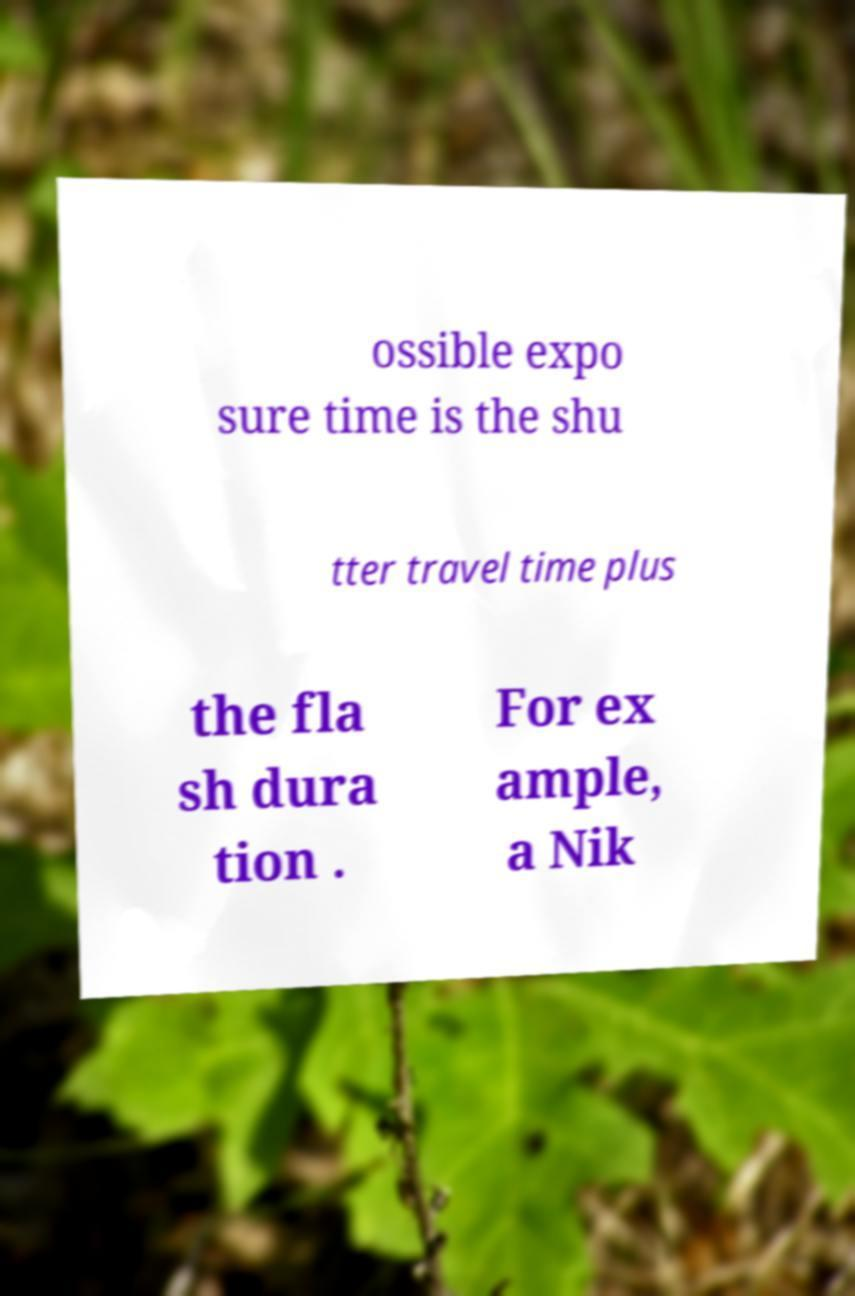I need the written content from this picture converted into text. Can you do that? ossible expo sure time is the shu tter travel time plus the fla sh dura tion . For ex ample, a Nik 